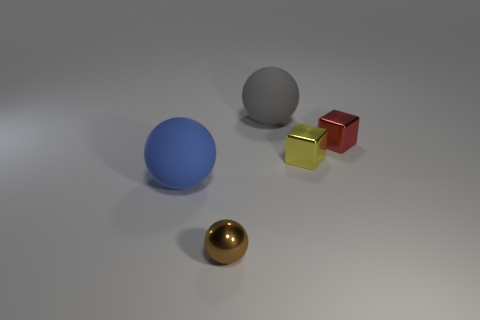Add 3 small metallic cubes. How many objects exist? 8 Subtract all cubes. How many objects are left? 3 Subtract all metallic cylinders. Subtract all small metallic spheres. How many objects are left? 4 Add 3 red blocks. How many red blocks are left? 4 Add 2 green spheres. How many green spheres exist? 2 Subtract 1 blue balls. How many objects are left? 4 